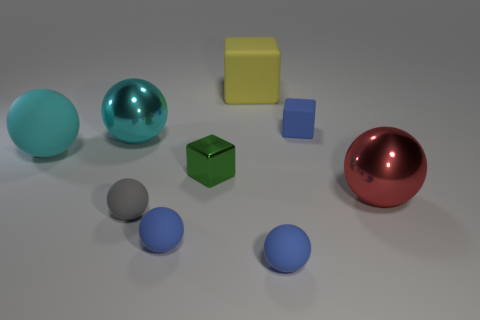Is the shape of the gray rubber object the same as the small green thing?
Keep it short and to the point. No. Are there any other things that have the same material as the tiny gray object?
Your response must be concise. Yes. There is a blue matte object that is behind the big cyan rubber ball; is its size the same as the cyan sphere behind the cyan rubber object?
Ensure brevity in your answer.  No. What is the small blue object that is in front of the gray rubber thing and on the right side of the green object made of?
Your answer should be very brief. Rubber. Is there anything else that has the same color as the metal cube?
Ensure brevity in your answer.  No. Are there fewer cyan shiny balls that are behind the yellow object than large green matte balls?
Ensure brevity in your answer.  No. Are there more big green cylinders than small rubber objects?
Provide a succinct answer. No. Are there any metallic things that are to the left of the metallic sphere to the left of the blue thing to the left of the green shiny cube?
Provide a succinct answer. No. What number of other things are the same size as the red metal ball?
Your answer should be very brief. 3. There is a tiny green metal cube; are there any big red metallic balls left of it?
Ensure brevity in your answer.  No. 